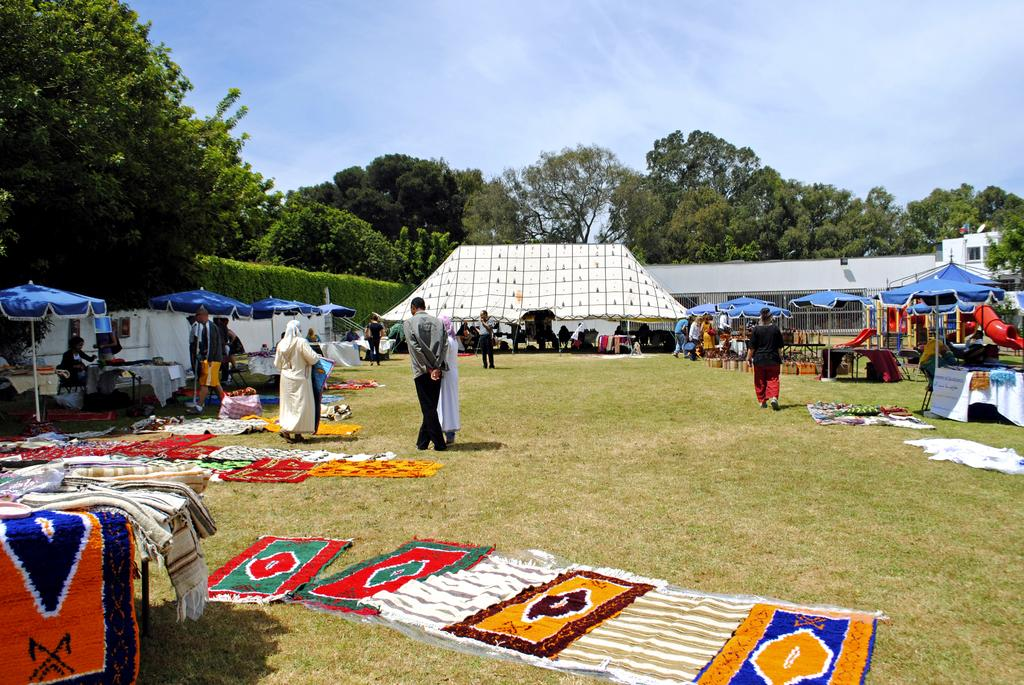What type of structures are present in the image? There are stalls in the image. What type of ground surface is visible at the bottom of the image? There is grass at the bottom of the image. What can be seen in the background of the image? There are trees in the background of the image. What is visible at the top of the image? The sky is visible at the top of the image. What type of coil is used to power the stoves in the image? There are no stoves present in the image, so there is no coil used for powering them. 